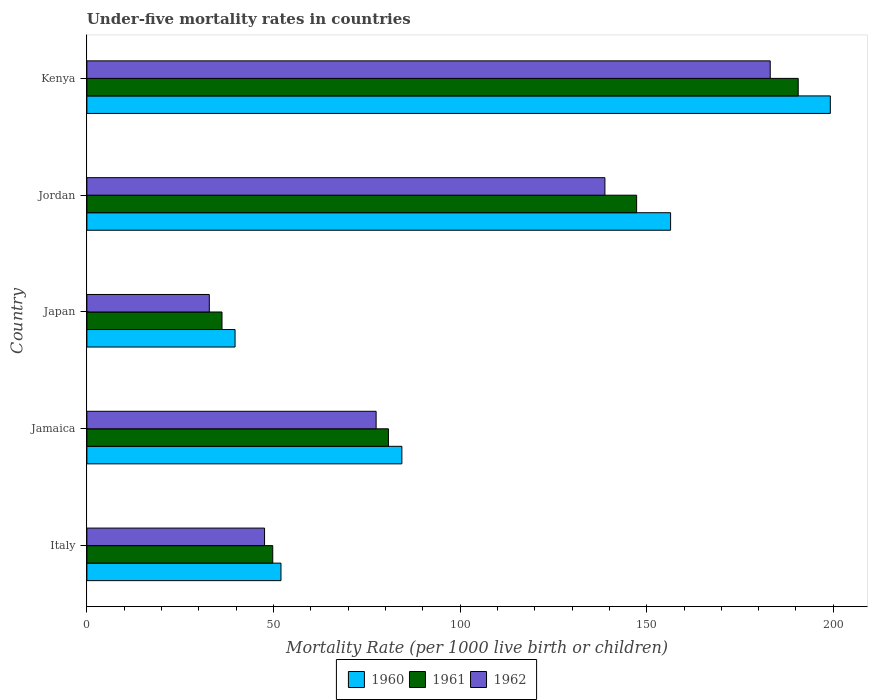How many different coloured bars are there?
Provide a succinct answer. 3. Are the number of bars per tick equal to the number of legend labels?
Offer a very short reply. Yes. How many bars are there on the 4th tick from the top?
Give a very brief answer. 3. What is the label of the 2nd group of bars from the top?
Make the answer very short. Jordan. What is the under-five mortality rate in 1961 in Jordan?
Provide a short and direct response. 147.3. Across all countries, what is the maximum under-five mortality rate in 1961?
Make the answer very short. 190.6. Across all countries, what is the minimum under-five mortality rate in 1962?
Make the answer very short. 32.8. In which country was the under-five mortality rate in 1961 maximum?
Your answer should be compact. Kenya. In which country was the under-five mortality rate in 1962 minimum?
Ensure brevity in your answer.  Japan. What is the total under-five mortality rate in 1961 in the graph?
Keep it short and to the point. 504.7. What is the difference between the under-five mortality rate in 1961 in Jamaica and that in Japan?
Make the answer very short. 44.6. What is the difference between the under-five mortality rate in 1960 in Italy and the under-five mortality rate in 1962 in Kenya?
Ensure brevity in your answer.  -131.1. What is the average under-five mortality rate in 1960 per country?
Give a very brief answer. 106.34. What is the difference between the under-five mortality rate in 1961 and under-five mortality rate in 1960 in Jordan?
Provide a short and direct response. -9.1. In how many countries, is the under-five mortality rate in 1960 greater than 40 ?
Offer a very short reply. 4. What is the ratio of the under-five mortality rate in 1962 in Jamaica to that in Kenya?
Offer a very short reply. 0.42. Is the under-five mortality rate in 1960 in Jamaica less than that in Japan?
Your response must be concise. No. Is the difference between the under-five mortality rate in 1961 in Jamaica and Japan greater than the difference between the under-five mortality rate in 1960 in Jamaica and Japan?
Give a very brief answer. No. What is the difference between the highest and the second highest under-five mortality rate in 1960?
Offer a terse response. 42.8. What is the difference between the highest and the lowest under-five mortality rate in 1960?
Ensure brevity in your answer.  159.5. In how many countries, is the under-five mortality rate in 1961 greater than the average under-five mortality rate in 1961 taken over all countries?
Your response must be concise. 2. Is the sum of the under-five mortality rate in 1961 in Jamaica and Japan greater than the maximum under-five mortality rate in 1960 across all countries?
Your response must be concise. No. Are the values on the major ticks of X-axis written in scientific E-notation?
Your response must be concise. No. Does the graph contain any zero values?
Keep it short and to the point. No. Where does the legend appear in the graph?
Your answer should be very brief. Bottom center. How many legend labels are there?
Provide a short and direct response. 3. What is the title of the graph?
Keep it short and to the point. Under-five mortality rates in countries. Does "1977" appear as one of the legend labels in the graph?
Ensure brevity in your answer.  No. What is the label or title of the X-axis?
Provide a succinct answer. Mortality Rate (per 1000 live birth or children). What is the Mortality Rate (per 1000 live birth or children) of 1960 in Italy?
Give a very brief answer. 52. What is the Mortality Rate (per 1000 live birth or children) of 1961 in Italy?
Your response must be concise. 49.8. What is the Mortality Rate (per 1000 live birth or children) in 1962 in Italy?
Your response must be concise. 47.6. What is the Mortality Rate (per 1000 live birth or children) in 1960 in Jamaica?
Provide a succinct answer. 84.4. What is the Mortality Rate (per 1000 live birth or children) in 1961 in Jamaica?
Provide a succinct answer. 80.8. What is the Mortality Rate (per 1000 live birth or children) in 1962 in Jamaica?
Your answer should be very brief. 77.5. What is the Mortality Rate (per 1000 live birth or children) in 1960 in Japan?
Provide a succinct answer. 39.7. What is the Mortality Rate (per 1000 live birth or children) of 1961 in Japan?
Provide a short and direct response. 36.2. What is the Mortality Rate (per 1000 live birth or children) in 1962 in Japan?
Give a very brief answer. 32.8. What is the Mortality Rate (per 1000 live birth or children) in 1960 in Jordan?
Give a very brief answer. 156.4. What is the Mortality Rate (per 1000 live birth or children) in 1961 in Jordan?
Your answer should be very brief. 147.3. What is the Mortality Rate (per 1000 live birth or children) in 1962 in Jordan?
Keep it short and to the point. 138.8. What is the Mortality Rate (per 1000 live birth or children) in 1960 in Kenya?
Provide a short and direct response. 199.2. What is the Mortality Rate (per 1000 live birth or children) of 1961 in Kenya?
Your answer should be compact. 190.6. What is the Mortality Rate (per 1000 live birth or children) in 1962 in Kenya?
Ensure brevity in your answer.  183.1. Across all countries, what is the maximum Mortality Rate (per 1000 live birth or children) in 1960?
Provide a short and direct response. 199.2. Across all countries, what is the maximum Mortality Rate (per 1000 live birth or children) in 1961?
Provide a short and direct response. 190.6. Across all countries, what is the maximum Mortality Rate (per 1000 live birth or children) in 1962?
Your answer should be very brief. 183.1. Across all countries, what is the minimum Mortality Rate (per 1000 live birth or children) in 1960?
Your response must be concise. 39.7. Across all countries, what is the minimum Mortality Rate (per 1000 live birth or children) of 1961?
Provide a short and direct response. 36.2. Across all countries, what is the minimum Mortality Rate (per 1000 live birth or children) of 1962?
Keep it short and to the point. 32.8. What is the total Mortality Rate (per 1000 live birth or children) in 1960 in the graph?
Give a very brief answer. 531.7. What is the total Mortality Rate (per 1000 live birth or children) in 1961 in the graph?
Offer a terse response. 504.7. What is the total Mortality Rate (per 1000 live birth or children) in 1962 in the graph?
Make the answer very short. 479.8. What is the difference between the Mortality Rate (per 1000 live birth or children) in 1960 in Italy and that in Jamaica?
Provide a succinct answer. -32.4. What is the difference between the Mortality Rate (per 1000 live birth or children) in 1961 in Italy and that in Jamaica?
Offer a terse response. -31. What is the difference between the Mortality Rate (per 1000 live birth or children) in 1962 in Italy and that in Jamaica?
Give a very brief answer. -29.9. What is the difference between the Mortality Rate (per 1000 live birth or children) of 1962 in Italy and that in Japan?
Provide a short and direct response. 14.8. What is the difference between the Mortality Rate (per 1000 live birth or children) in 1960 in Italy and that in Jordan?
Give a very brief answer. -104.4. What is the difference between the Mortality Rate (per 1000 live birth or children) of 1961 in Italy and that in Jordan?
Offer a very short reply. -97.5. What is the difference between the Mortality Rate (per 1000 live birth or children) of 1962 in Italy and that in Jordan?
Provide a short and direct response. -91.2. What is the difference between the Mortality Rate (per 1000 live birth or children) in 1960 in Italy and that in Kenya?
Offer a terse response. -147.2. What is the difference between the Mortality Rate (per 1000 live birth or children) in 1961 in Italy and that in Kenya?
Your answer should be compact. -140.8. What is the difference between the Mortality Rate (per 1000 live birth or children) of 1962 in Italy and that in Kenya?
Your response must be concise. -135.5. What is the difference between the Mortality Rate (per 1000 live birth or children) in 1960 in Jamaica and that in Japan?
Your answer should be very brief. 44.7. What is the difference between the Mortality Rate (per 1000 live birth or children) in 1961 in Jamaica and that in Japan?
Make the answer very short. 44.6. What is the difference between the Mortality Rate (per 1000 live birth or children) in 1962 in Jamaica and that in Japan?
Ensure brevity in your answer.  44.7. What is the difference between the Mortality Rate (per 1000 live birth or children) of 1960 in Jamaica and that in Jordan?
Make the answer very short. -72. What is the difference between the Mortality Rate (per 1000 live birth or children) of 1961 in Jamaica and that in Jordan?
Keep it short and to the point. -66.5. What is the difference between the Mortality Rate (per 1000 live birth or children) of 1962 in Jamaica and that in Jordan?
Offer a very short reply. -61.3. What is the difference between the Mortality Rate (per 1000 live birth or children) in 1960 in Jamaica and that in Kenya?
Make the answer very short. -114.8. What is the difference between the Mortality Rate (per 1000 live birth or children) in 1961 in Jamaica and that in Kenya?
Ensure brevity in your answer.  -109.8. What is the difference between the Mortality Rate (per 1000 live birth or children) in 1962 in Jamaica and that in Kenya?
Your answer should be compact. -105.6. What is the difference between the Mortality Rate (per 1000 live birth or children) of 1960 in Japan and that in Jordan?
Keep it short and to the point. -116.7. What is the difference between the Mortality Rate (per 1000 live birth or children) in 1961 in Japan and that in Jordan?
Make the answer very short. -111.1. What is the difference between the Mortality Rate (per 1000 live birth or children) in 1962 in Japan and that in Jordan?
Your answer should be very brief. -106. What is the difference between the Mortality Rate (per 1000 live birth or children) of 1960 in Japan and that in Kenya?
Your response must be concise. -159.5. What is the difference between the Mortality Rate (per 1000 live birth or children) of 1961 in Japan and that in Kenya?
Provide a short and direct response. -154.4. What is the difference between the Mortality Rate (per 1000 live birth or children) in 1962 in Japan and that in Kenya?
Provide a succinct answer. -150.3. What is the difference between the Mortality Rate (per 1000 live birth or children) of 1960 in Jordan and that in Kenya?
Keep it short and to the point. -42.8. What is the difference between the Mortality Rate (per 1000 live birth or children) of 1961 in Jordan and that in Kenya?
Ensure brevity in your answer.  -43.3. What is the difference between the Mortality Rate (per 1000 live birth or children) in 1962 in Jordan and that in Kenya?
Keep it short and to the point. -44.3. What is the difference between the Mortality Rate (per 1000 live birth or children) of 1960 in Italy and the Mortality Rate (per 1000 live birth or children) of 1961 in Jamaica?
Make the answer very short. -28.8. What is the difference between the Mortality Rate (per 1000 live birth or children) in 1960 in Italy and the Mortality Rate (per 1000 live birth or children) in 1962 in Jamaica?
Provide a short and direct response. -25.5. What is the difference between the Mortality Rate (per 1000 live birth or children) in 1961 in Italy and the Mortality Rate (per 1000 live birth or children) in 1962 in Jamaica?
Your answer should be compact. -27.7. What is the difference between the Mortality Rate (per 1000 live birth or children) in 1960 in Italy and the Mortality Rate (per 1000 live birth or children) in 1961 in Japan?
Ensure brevity in your answer.  15.8. What is the difference between the Mortality Rate (per 1000 live birth or children) in 1960 in Italy and the Mortality Rate (per 1000 live birth or children) in 1962 in Japan?
Offer a terse response. 19.2. What is the difference between the Mortality Rate (per 1000 live birth or children) in 1961 in Italy and the Mortality Rate (per 1000 live birth or children) in 1962 in Japan?
Offer a terse response. 17. What is the difference between the Mortality Rate (per 1000 live birth or children) of 1960 in Italy and the Mortality Rate (per 1000 live birth or children) of 1961 in Jordan?
Ensure brevity in your answer.  -95.3. What is the difference between the Mortality Rate (per 1000 live birth or children) of 1960 in Italy and the Mortality Rate (per 1000 live birth or children) of 1962 in Jordan?
Keep it short and to the point. -86.8. What is the difference between the Mortality Rate (per 1000 live birth or children) in 1961 in Italy and the Mortality Rate (per 1000 live birth or children) in 1962 in Jordan?
Your answer should be very brief. -89. What is the difference between the Mortality Rate (per 1000 live birth or children) in 1960 in Italy and the Mortality Rate (per 1000 live birth or children) in 1961 in Kenya?
Provide a short and direct response. -138.6. What is the difference between the Mortality Rate (per 1000 live birth or children) of 1960 in Italy and the Mortality Rate (per 1000 live birth or children) of 1962 in Kenya?
Offer a very short reply. -131.1. What is the difference between the Mortality Rate (per 1000 live birth or children) in 1961 in Italy and the Mortality Rate (per 1000 live birth or children) in 1962 in Kenya?
Make the answer very short. -133.3. What is the difference between the Mortality Rate (per 1000 live birth or children) of 1960 in Jamaica and the Mortality Rate (per 1000 live birth or children) of 1961 in Japan?
Your response must be concise. 48.2. What is the difference between the Mortality Rate (per 1000 live birth or children) in 1960 in Jamaica and the Mortality Rate (per 1000 live birth or children) in 1962 in Japan?
Provide a succinct answer. 51.6. What is the difference between the Mortality Rate (per 1000 live birth or children) of 1961 in Jamaica and the Mortality Rate (per 1000 live birth or children) of 1962 in Japan?
Your response must be concise. 48. What is the difference between the Mortality Rate (per 1000 live birth or children) of 1960 in Jamaica and the Mortality Rate (per 1000 live birth or children) of 1961 in Jordan?
Your answer should be compact. -62.9. What is the difference between the Mortality Rate (per 1000 live birth or children) in 1960 in Jamaica and the Mortality Rate (per 1000 live birth or children) in 1962 in Jordan?
Offer a very short reply. -54.4. What is the difference between the Mortality Rate (per 1000 live birth or children) in 1961 in Jamaica and the Mortality Rate (per 1000 live birth or children) in 1962 in Jordan?
Your answer should be compact. -58. What is the difference between the Mortality Rate (per 1000 live birth or children) in 1960 in Jamaica and the Mortality Rate (per 1000 live birth or children) in 1961 in Kenya?
Keep it short and to the point. -106.2. What is the difference between the Mortality Rate (per 1000 live birth or children) in 1960 in Jamaica and the Mortality Rate (per 1000 live birth or children) in 1962 in Kenya?
Provide a succinct answer. -98.7. What is the difference between the Mortality Rate (per 1000 live birth or children) in 1961 in Jamaica and the Mortality Rate (per 1000 live birth or children) in 1962 in Kenya?
Your answer should be compact. -102.3. What is the difference between the Mortality Rate (per 1000 live birth or children) in 1960 in Japan and the Mortality Rate (per 1000 live birth or children) in 1961 in Jordan?
Give a very brief answer. -107.6. What is the difference between the Mortality Rate (per 1000 live birth or children) of 1960 in Japan and the Mortality Rate (per 1000 live birth or children) of 1962 in Jordan?
Provide a succinct answer. -99.1. What is the difference between the Mortality Rate (per 1000 live birth or children) in 1961 in Japan and the Mortality Rate (per 1000 live birth or children) in 1962 in Jordan?
Give a very brief answer. -102.6. What is the difference between the Mortality Rate (per 1000 live birth or children) in 1960 in Japan and the Mortality Rate (per 1000 live birth or children) in 1961 in Kenya?
Provide a short and direct response. -150.9. What is the difference between the Mortality Rate (per 1000 live birth or children) in 1960 in Japan and the Mortality Rate (per 1000 live birth or children) in 1962 in Kenya?
Keep it short and to the point. -143.4. What is the difference between the Mortality Rate (per 1000 live birth or children) in 1961 in Japan and the Mortality Rate (per 1000 live birth or children) in 1962 in Kenya?
Your answer should be compact. -146.9. What is the difference between the Mortality Rate (per 1000 live birth or children) of 1960 in Jordan and the Mortality Rate (per 1000 live birth or children) of 1961 in Kenya?
Your response must be concise. -34.2. What is the difference between the Mortality Rate (per 1000 live birth or children) of 1960 in Jordan and the Mortality Rate (per 1000 live birth or children) of 1962 in Kenya?
Give a very brief answer. -26.7. What is the difference between the Mortality Rate (per 1000 live birth or children) of 1961 in Jordan and the Mortality Rate (per 1000 live birth or children) of 1962 in Kenya?
Make the answer very short. -35.8. What is the average Mortality Rate (per 1000 live birth or children) of 1960 per country?
Make the answer very short. 106.34. What is the average Mortality Rate (per 1000 live birth or children) of 1961 per country?
Your answer should be compact. 100.94. What is the average Mortality Rate (per 1000 live birth or children) in 1962 per country?
Offer a very short reply. 95.96. What is the difference between the Mortality Rate (per 1000 live birth or children) of 1961 and Mortality Rate (per 1000 live birth or children) of 1962 in Italy?
Provide a succinct answer. 2.2. What is the difference between the Mortality Rate (per 1000 live birth or children) in 1960 and Mortality Rate (per 1000 live birth or children) in 1962 in Jamaica?
Give a very brief answer. 6.9. What is the difference between the Mortality Rate (per 1000 live birth or children) in 1961 and Mortality Rate (per 1000 live birth or children) in 1962 in Jamaica?
Make the answer very short. 3.3. What is the difference between the Mortality Rate (per 1000 live birth or children) of 1961 and Mortality Rate (per 1000 live birth or children) of 1962 in Japan?
Make the answer very short. 3.4. What is the difference between the Mortality Rate (per 1000 live birth or children) in 1960 and Mortality Rate (per 1000 live birth or children) in 1961 in Jordan?
Your response must be concise. 9.1. What is the difference between the Mortality Rate (per 1000 live birth or children) in 1960 and Mortality Rate (per 1000 live birth or children) in 1961 in Kenya?
Provide a short and direct response. 8.6. What is the ratio of the Mortality Rate (per 1000 live birth or children) in 1960 in Italy to that in Jamaica?
Offer a very short reply. 0.62. What is the ratio of the Mortality Rate (per 1000 live birth or children) in 1961 in Italy to that in Jamaica?
Provide a short and direct response. 0.62. What is the ratio of the Mortality Rate (per 1000 live birth or children) in 1962 in Italy to that in Jamaica?
Make the answer very short. 0.61. What is the ratio of the Mortality Rate (per 1000 live birth or children) of 1960 in Italy to that in Japan?
Make the answer very short. 1.31. What is the ratio of the Mortality Rate (per 1000 live birth or children) in 1961 in Italy to that in Japan?
Offer a terse response. 1.38. What is the ratio of the Mortality Rate (per 1000 live birth or children) of 1962 in Italy to that in Japan?
Keep it short and to the point. 1.45. What is the ratio of the Mortality Rate (per 1000 live birth or children) in 1960 in Italy to that in Jordan?
Provide a short and direct response. 0.33. What is the ratio of the Mortality Rate (per 1000 live birth or children) in 1961 in Italy to that in Jordan?
Your answer should be compact. 0.34. What is the ratio of the Mortality Rate (per 1000 live birth or children) in 1962 in Italy to that in Jordan?
Ensure brevity in your answer.  0.34. What is the ratio of the Mortality Rate (per 1000 live birth or children) of 1960 in Italy to that in Kenya?
Provide a short and direct response. 0.26. What is the ratio of the Mortality Rate (per 1000 live birth or children) of 1961 in Italy to that in Kenya?
Give a very brief answer. 0.26. What is the ratio of the Mortality Rate (per 1000 live birth or children) in 1962 in Italy to that in Kenya?
Give a very brief answer. 0.26. What is the ratio of the Mortality Rate (per 1000 live birth or children) of 1960 in Jamaica to that in Japan?
Offer a terse response. 2.13. What is the ratio of the Mortality Rate (per 1000 live birth or children) in 1961 in Jamaica to that in Japan?
Give a very brief answer. 2.23. What is the ratio of the Mortality Rate (per 1000 live birth or children) of 1962 in Jamaica to that in Japan?
Offer a very short reply. 2.36. What is the ratio of the Mortality Rate (per 1000 live birth or children) in 1960 in Jamaica to that in Jordan?
Ensure brevity in your answer.  0.54. What is the ratio of the Mortality Rate (per 1000 live birth or children) in 1961 in Jamaica to that in Jordan?
Offer a very short reply. 0.55. What is the ratio of the Mortality Rate (per 1000 live birth or children) of 1962 in Jamaica to that in Jordan?
Provide a succinct answer. 0.56. What is the ratio of the Mortality Rate (per 1000 live birth or children) of 1960 in Jamaica to that in Kenya?
Offer a terse response. 0.42. What is the ratio of the Mortality Rate (per 1000 live birth or children) in 1961 in Jamaica to that in Kenya?
Ensure brevity in your answer.  0.42. What is the ratio of the Mortality Rate (per 1000 live birth or children) in 1962 in Jamaica to that in Kenya?
Your response must be concise. 0.42. What is the ratio of the Mortality Rate (per 1000 live birth or children) in 1960 in Japan to that in Jordan?
Provide a succinct answer. 0.25. What is the ratio of the Mortality Rate (per 1000 live birth or children) of 1961 in Japan to that in Jordan?
Your response must be concise. 0.25. What is the ratio of the Mortality Rate (per 1000 live birth or children) in 1962 in Japan to that in Jordan?
Offer a very short reply. 0.24. What is the ratio of the Mortality Rate (per 1000 live birth or children) in 1960 in Japan to that in Kenya?
Your answer should be compact. 0.2. What is the ratio of the Mortality Rate (per 1000 live birth or children) of 1961 in Japan to that in Kenya?
Offer a terse response. 0.19. What is the ratio of the Mortality Rate (per 1000 live birth or children) of 1962 in Japan to that in Kenya?
Keep it short and to the point. 0.18. What is the ratio of the Mortality Rate (per 1000 live birth or children) of 1960 in Jordan to that in Kenya?
Offer a very short reply. 0.79. What is the ratio of the Mortality Rate (per 1000 live birth or children) of 1961 in Jordan to that in Kenya?
Provide a short and direct response. 0.77. What is the ratio of the Mortality Rate (per 1000 live birth or children) of 1962 in Jordan to that in Kenya?
Ensure brevity in your answer.  0.76. What is the difference between the highest and the second highest Mortality Rate (per 1000 live birth or children) of 1960?
Provide a short and direct response. 42.8. What is the difference between the highest and the second highest Mortality Rate (per 1000 live birth or children) in 1961?
Your answer should be compact. 43.3. What is the difference between the highest and the second highest Mortality Rate (per 1000 live birth or children) of 1962?
Keep it short and to the point. 44.3. What is the difference between the highest and the lowest Mortality Rate (per 1000 live birth or children) in 1960?
Offer a terse response. 159.5. What is the difference between the highest and the lowest Mortality Rate (per 1000 live birth or children) in 1961?
Give a very brief answer. 154.4. What is the difference between the highest and the lowest Mortality Rate (per 1000 live birth or children) of 1962?
Give a very brief answer. 150.3. 